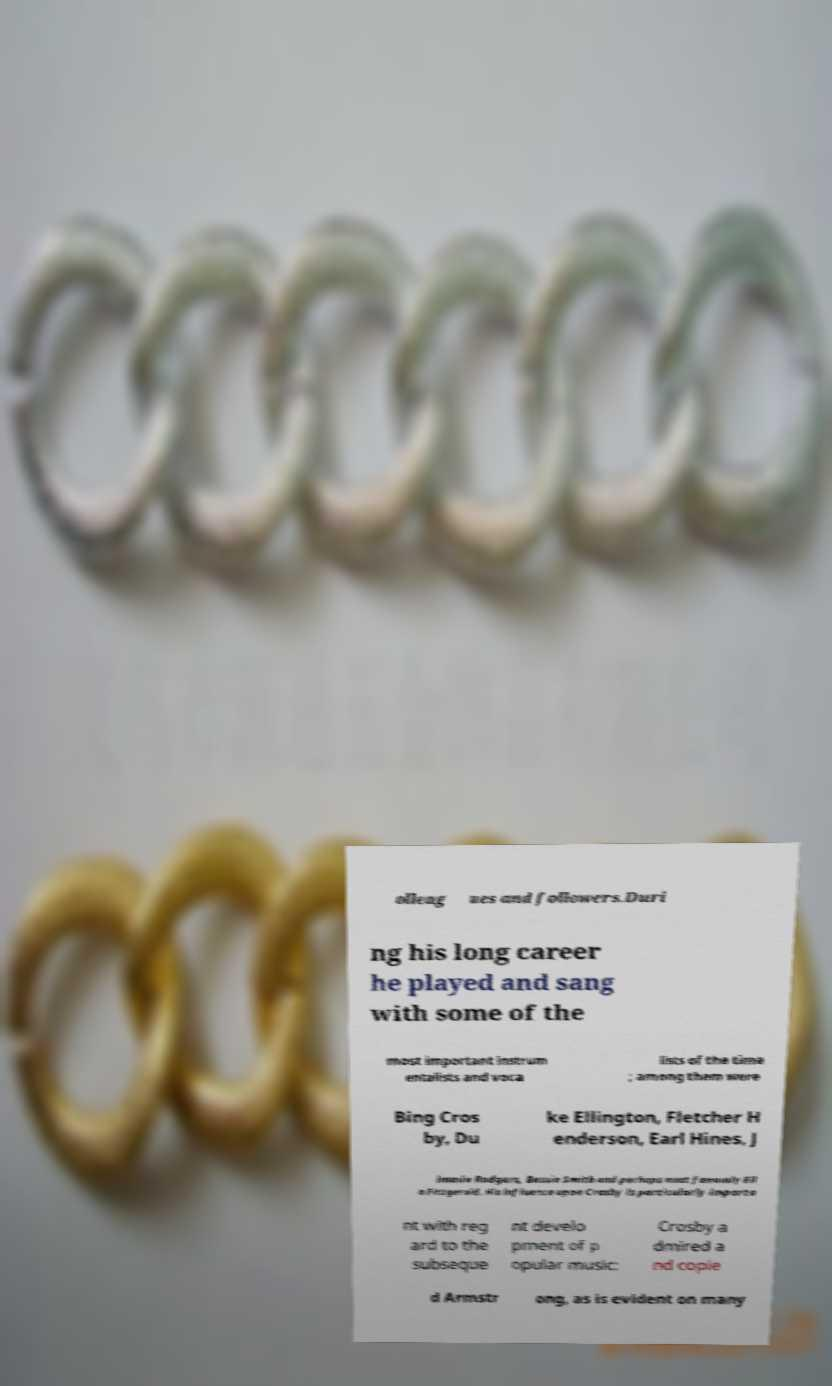Please identify and transcribe the text found in this image. olleag ues and followers.Duri ng his long career he played and sang with some of the most important instrum entalists and voca lists of the time ; among them were Bing Cros by, Du ke Ellington, Fletcher H enderson, Earl Hines, J immie Rodgers, Bessie Smith and perhaps most famously Ell a Fitzgerald. His influence upon Crosby is particularly importa nt with reg ard to the subseque nt develo pment of p opular music: Crosby a dmired a nd copie d Armstr ong, as is evident on many 